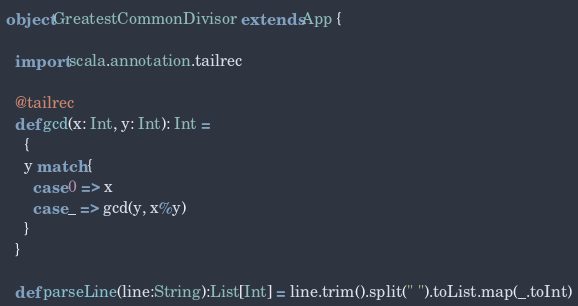<code> <loc_0><loc_0><loc_500><loc_500><_Scala_>object GreatestCommonDivisor extends App {

  import scala.annotation.tailrec
  
  @tailrec
  def gcd(x: Int, y: Int): Int =
	{
    y match {
      case 0 => x
      case _ => gcd(y, x%y)
    }
  }
  
  def parseLine(line:String):List[Int] = line.trim().split(" ").toList.map(_.toInt)
</code> 